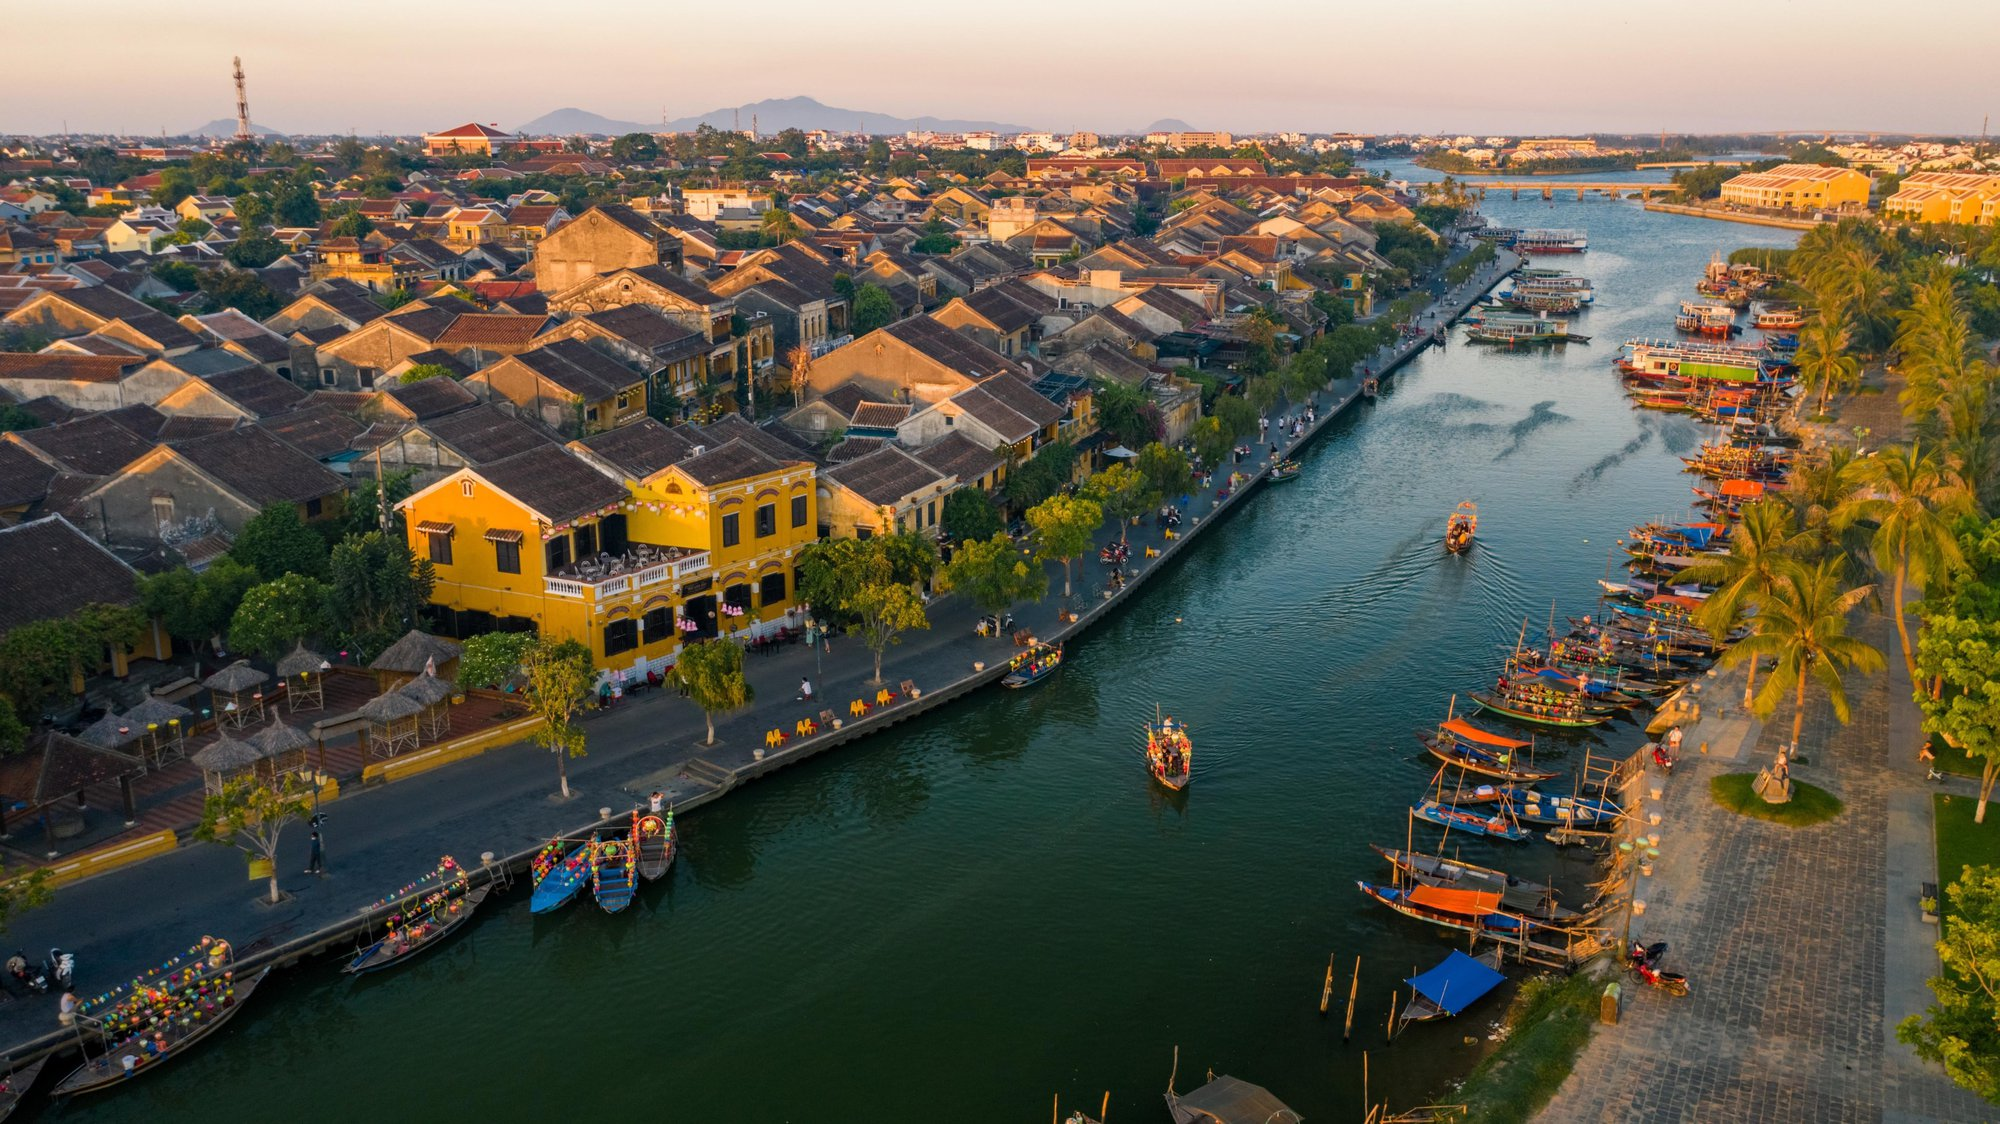Explain the visual content of the image in great detail. The image presents a breathtaking aerial view of Hoi An, an ancient town in Vietnam recognized as a UNESCO World Heritage site. The golden hour casts a serene glow over the landscape, highlighting the vibrant architectural palette characteristic of Hoi An. The Thu Bon River, central in the frame, serves as a bustling artery for traditional wooden boats adorned with colorful lanterns, reflecting a lively yet tranquil river life. Along the banks, yellow and terracotta buildings with traditional Vietnamese architectural designs stand prominently, showcasing the historical and cultural amalgamation of indigenous and colonial influences. The image also includes glimpses of daily life with locals and tourists milling about the riverside, engaging in commerce or enjoying the serene views, adding a dynamic human element to the tranquil historical site. 